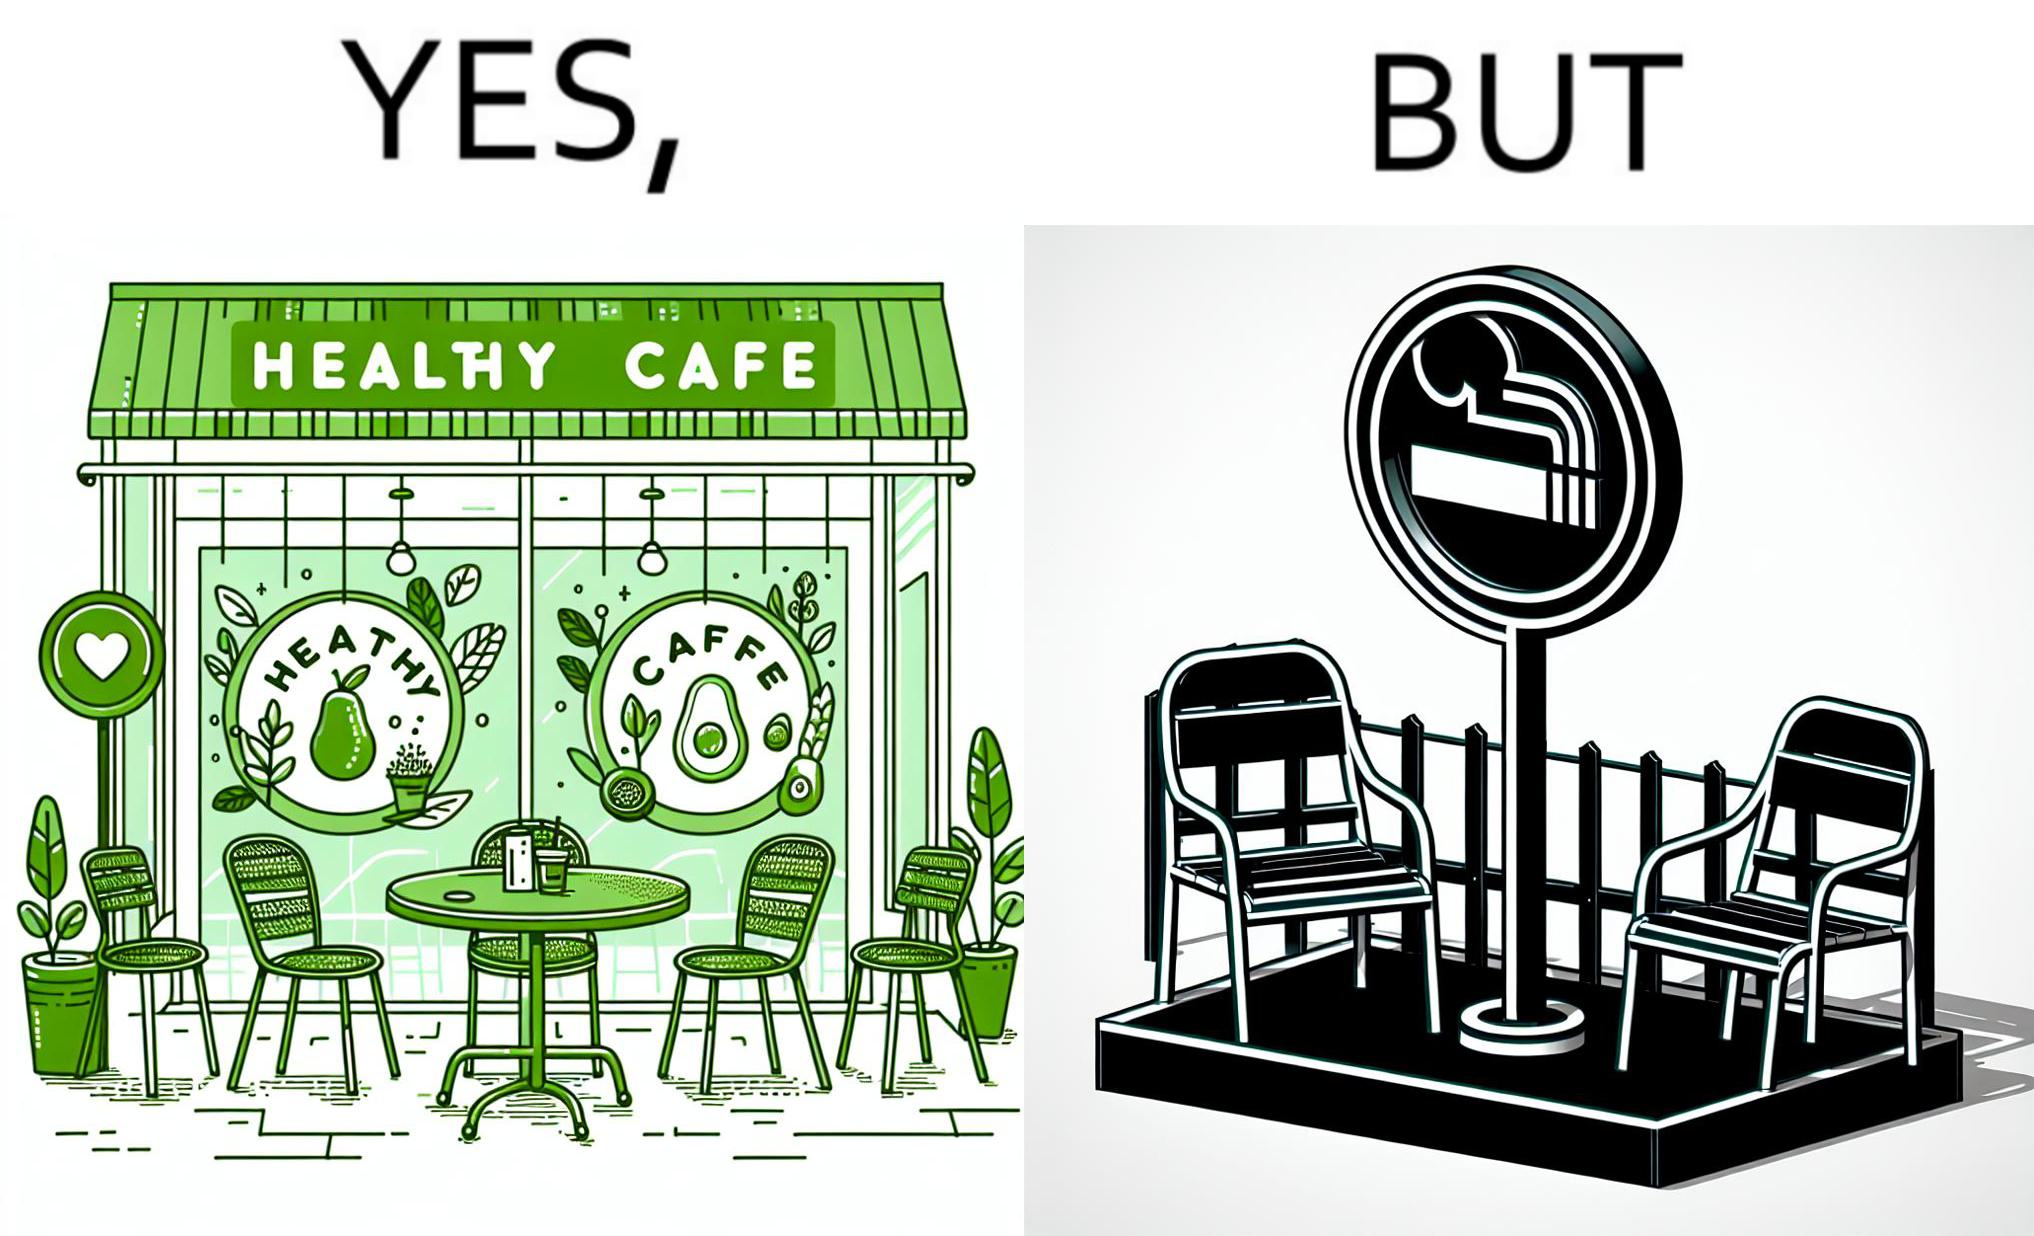What is shown in this image? This image is funny because an eatery that calls itself the "healthy" cafe also has a smoking area, which is not very "healthy". If it really was a healthy cafe, it would not have a smoking area as smoking is injurious to health. Satire on the behavior of humans - both those that operate this cafe who made the decision of allowing smoking and creating a designated smoking area, and those that visit this healthy cafe to become "healthy", but then also indulge in very unhealthy habits simultaneously. 